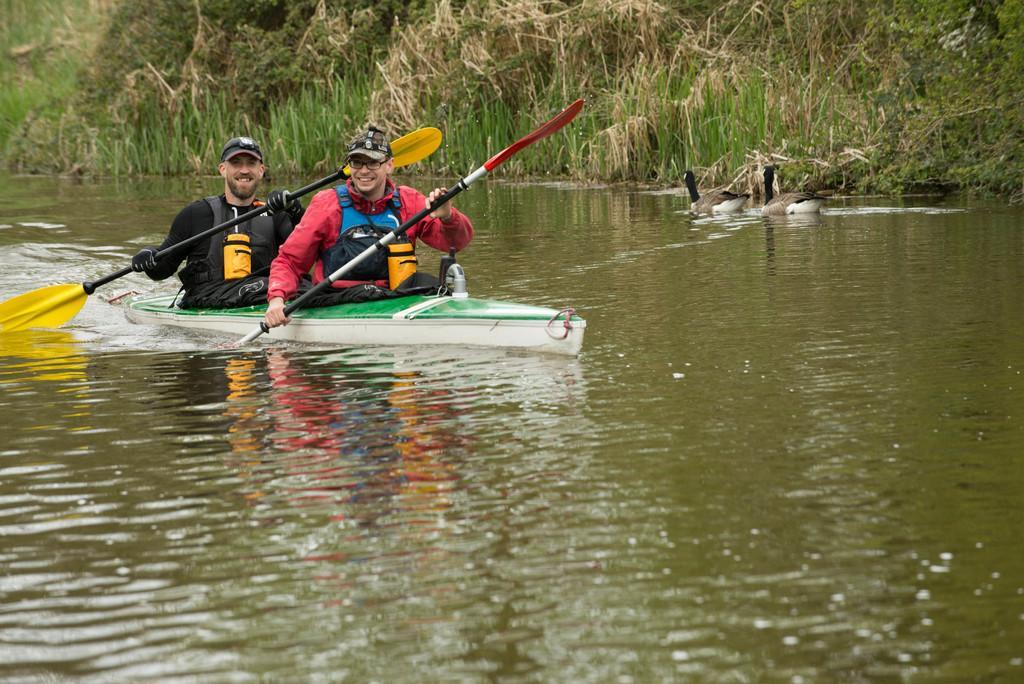Can you describe this image briefly? In this image I see a canoe on which there are 2 men who are holding paddles in their hands and both of them are smiling and I see caps on their heads and I see the water and I see 2 ducks over here. In the background I see the grass. 